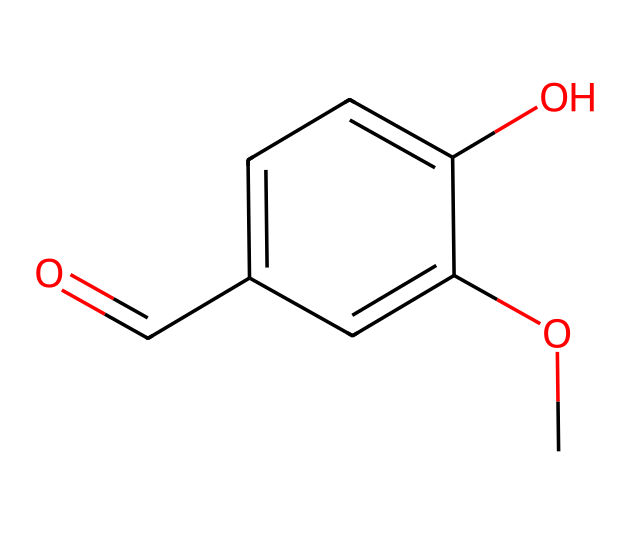What is the molecular formula of vanillin? To determine the molecular formula, we analyze the SMILES representation. The components include 8 carbon (C) atoms, 8 hydrogen (H) atoms, and 3 oxygen (O) atoms. Therefore, combining these gives the formula C8H8O3.
Answer: C8H8O3 How many oxygen atoms are present in vanillin? By examining the SMILES structure, there are three distinct 'O' symbols which represent oxygen atoms.
Answer: 3 What functional groups are present in vanillin? The SMILES representation indicates an aldehyde (from the O=C group), a hydroxyl (from the -OH), and a methoxy (from the -OCH3). This demonstrates the presence of various functional groups in the molecule.
Answer: aldehyde, hydroxyl, methoxy How many aromatic rings are in the structure of vanillin? The chemical structure contains a benzene ring as indicated by the alternating double bonds connected by single bonds among carbon atoms. Thus, there is one aromatic ring present.
Answer: 1 What characteristic property does the methoxy group (-OCH3) provide to vanillin? The methoxy group is an electron-donating group, which stabilizes the aromatic system and influences the overall fragrance quality of vanillin, enhancing its sweet and creamy notes.
Answer: sweet, creamy notes Which part of the molecular structure contributes to vanillin's characteristic odor? The aldehyde group (O=C) in the chemical structure is predominantly responsible for its characteristic fragrance, as aldehydes are known to impart strong aromatic properties.
Answer: aldehyde group What is the overall hybridization of the carbon atoms in the aromatic part of vanillin? In the aromatic ring of vanillin, the carbon atoms are involved in forming double bonds and single bonds, indicating that the carbon atoms are sp2 hybridized due to the planar arrangement and bond angles associated with aromatic compounds.
Answer: sp2 